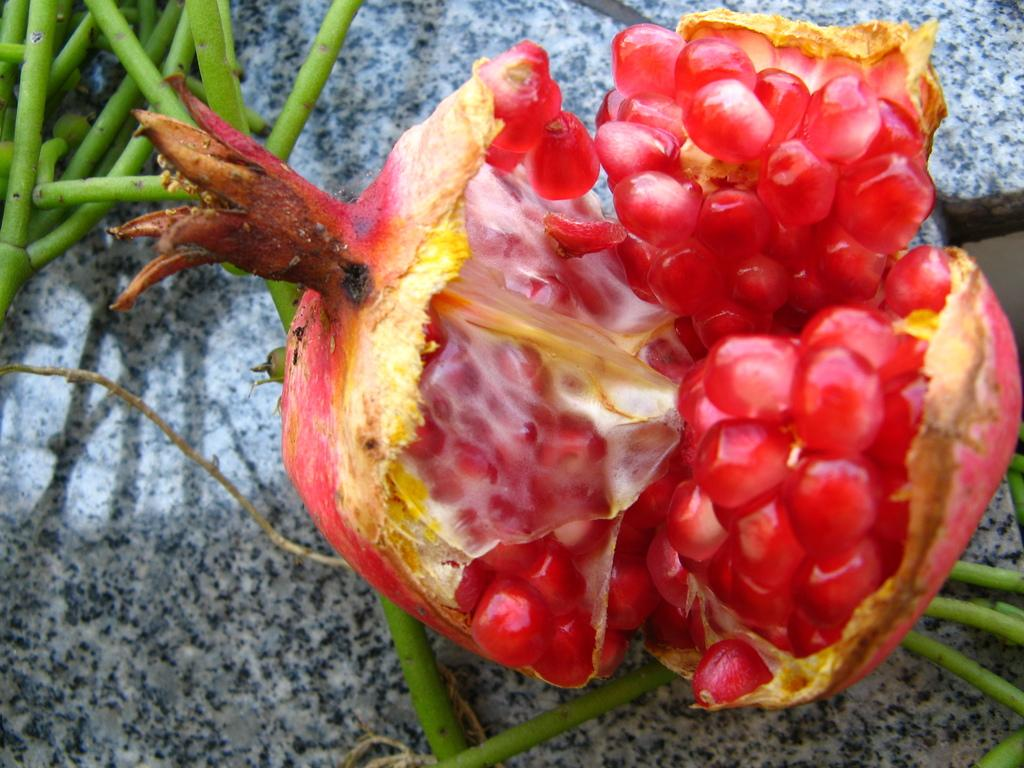What type of fruit is in the image? There is a pomegranate in the image. What other object can be seen in the image? There is a stone in the image. What type of plant material is present in the image? There are plant stems in the image. Can you see the river flowing in the background of the image? A: There is no river present in the image. 